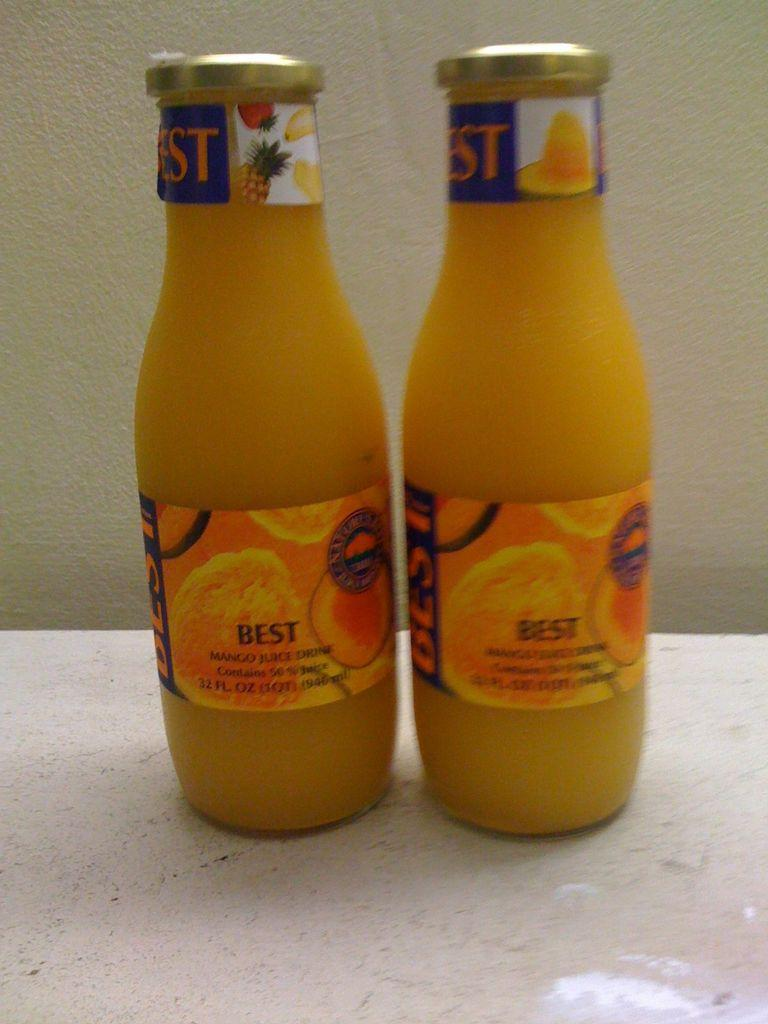<image>
Present a compact description of the photo's key features. Two bottles of Best branded orange juice have gold coloured tops. 